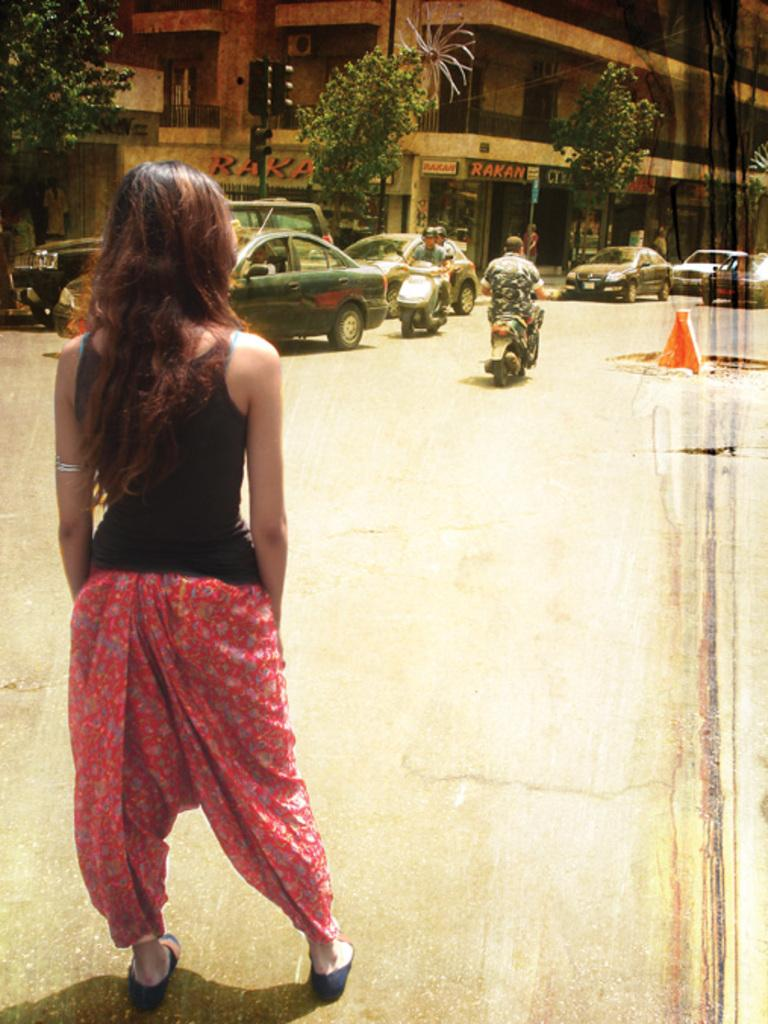What types of vehicles are present in the image? There are cars and motorcycles in the image. What are the vehicles doing in the image? The vehicles are moving on the road. Can you describe the woman in the image? There is a woman standing in the image. What other elements can be seen in the image? There are trees, a building, and a cone on the road in the image. What type of jewel is the woman wearing in the image? There is no mention of a jewel in the image; the woman is simply standing. What is the woman eating for breakfast in the image? There is no mention of food, specifically oatmeal, in the image. 